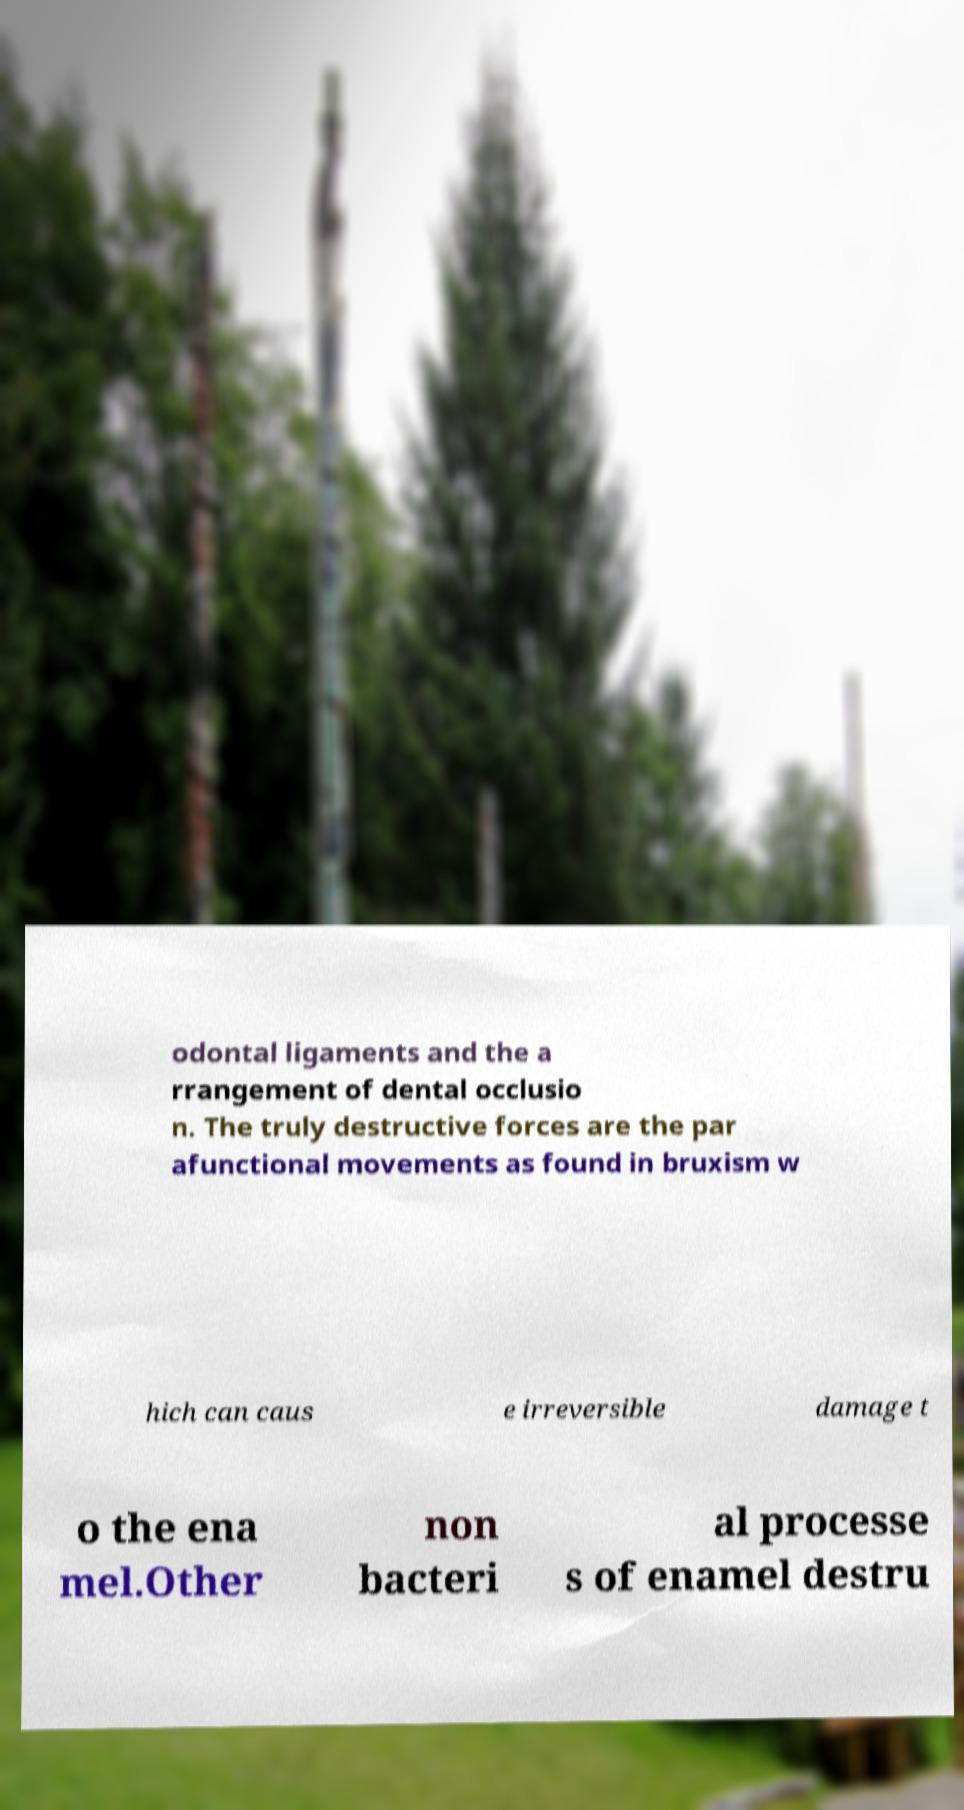What messages or text are displayed in this image? I need them in a readable, typed format. odontal ligaments and the a rrangement of dental occlusio n. The truly destructive forces are the par afunctional movements as found in bruxism w hich can caus e irreversible damage t o the ena mel.Other non bacteri al processe s of enamel destru 